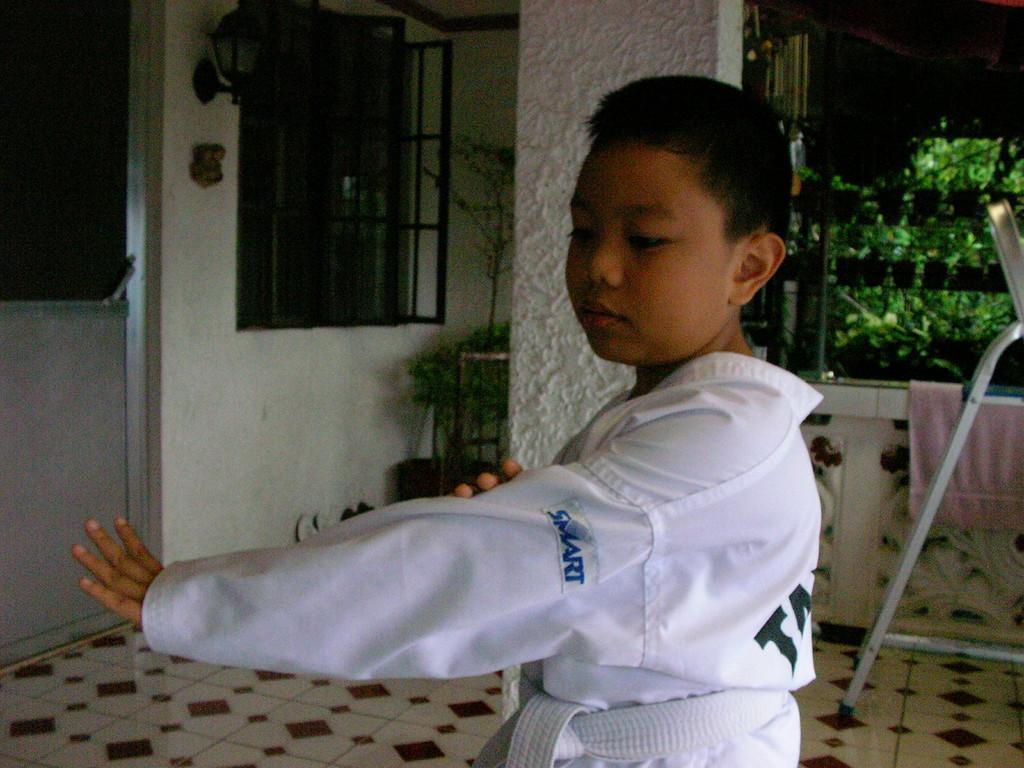Can you describe this image briefly? In this image, we can see a boy performing martial arts. In the background, there are house plants, pillar, glass objects, door, rod stand, railing with towel and few objects. At the bottom of the image, there is a floor. 